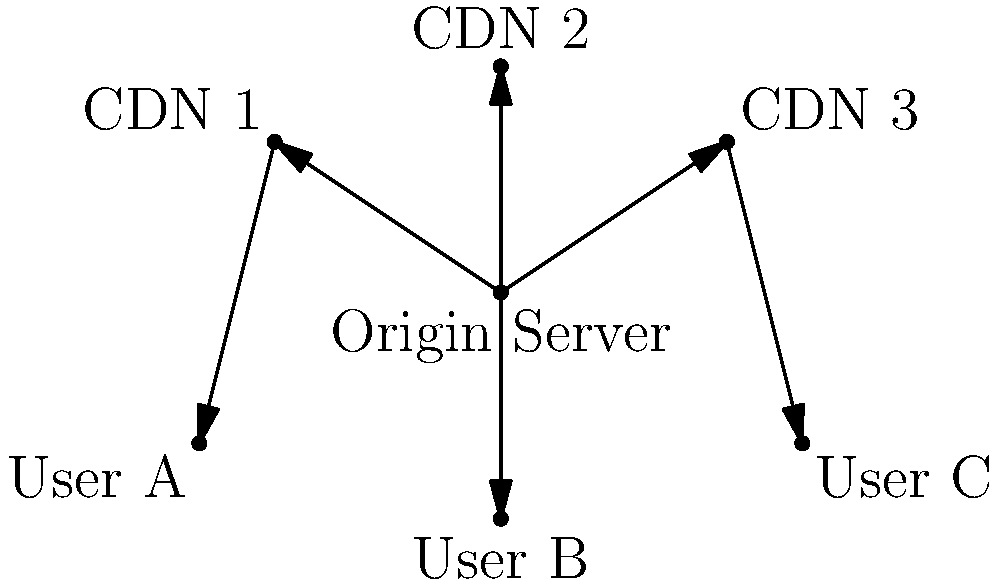Based on the CDN architecture diagram, which component should be optimized to reduce latency for User B when accessing content? To determine which component should be optimized to reduce latency for User B, let's analyze the CDN architecture diagram step-by-step:

1. The diagram shows an Origin Server connected to three CDN nodes (CDN 1, CDN 2, and CDN 3).
2. Each CDN node is connected to a specific user (User A, User B, and User C).
3. User B is directly connected to CDN 2.
4. The goal is to reduce latency for User B when accessing content.

To optimize content delivery and reduce latency for User B:

1. Focus on the path between the Origin Server and User B.
2. The content flows from the Origin Server to CDN 2, and then to User B.
3. CDN 2 acts as an intermediary cache between the Origin Server and User B.
4. By optimizing CDN 2, we can improve content caching, reduce the need for requests to the Origin Server, and decrease the overall latency for User B.

Therefore, the component that should be optimized to reduce latency for User B is CDN 2.
Answer: CDN 2 